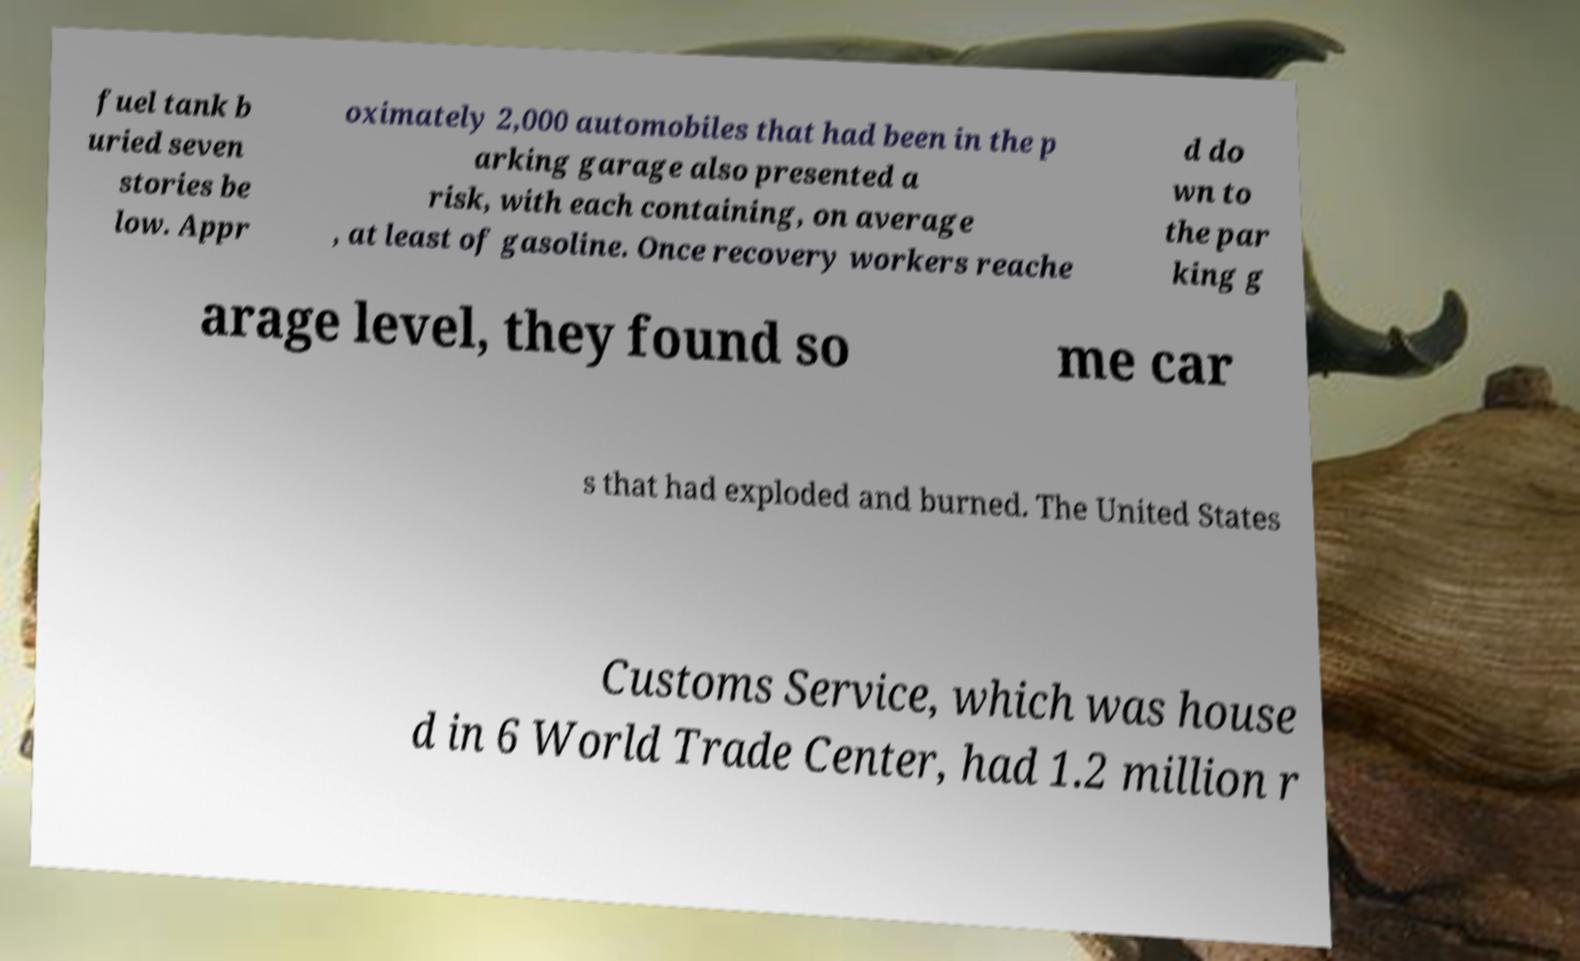Could you extract and type out the text from this image? fuel tank b uried seven stories be low. Appr oximately 2,000 automobiles that had been in the p arking garage also presented a risk, with each containing, on average , at least of gasoline. Once recovery workers reache d do wn to the par king g arage level, they found so me car s that had exploded and burned. The United States Customs Service, which was house d in 6 World Trade Center, had 1.2 million r 